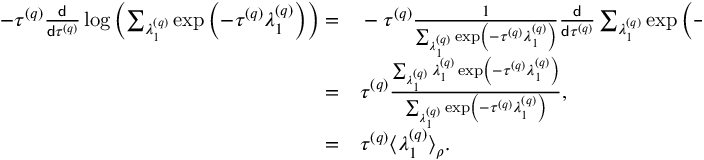<formula> <loc_0><loc_0><loc_500><loc_500>\begin{array} { r l } { - \tau ^ { \left ( q \right ) } \frac { d } { d \tau ^ { \left ( q \right ) } } \log \left ( \sum _ { \lambda _ { 1 } ^ { \left ( q \right ) } } \exp \left ( - \tau ^ { \left ( q \right ) } \lambda _ { 1 } ^ { \left ( q \right ) } \right ) \right ) = } & - \tau ^ { \left ( q \right ) } \frac { 1 } { \sum _ { \lambda _ { 1 } ^ { \left ( q \right ) } } \exp \left ( - \tau ^ { \left ( q \right ) } \lambda _ { 1 } ^ { \left ( q \right ) } \right ) } \frac { d } { d \tau ^ { \left ( q \right ) } } \sum _ { \lambda _ { 1 } ^ { \left ( q \right ) } } \exp \left ( - \tau ^ { \left ( q \right ) } \lambda _ { 1 } ^ { \left ( q \right ) } \right ) , } \\ { = } & \tau ^ { \left ( q \right ) } \frac { \sum _ { \lambda _ { 1 } ^ { \left ( q \right ) } } \lambda _ { 1 } ^ { \left ( q \right ) } \exp \left ( - \tau ^ { \left ( q \right ) } \lambda _ { 1 } ^ { \left ( q \right ) } \right ) } { \sum _ { \lambda _ { 1 } ^ { \left ( q \right ) } } \exp \left ( - \tau ^ { \left ( q \right ) } \lambda _ { 1 } ^ { \left ( q \right ) } \right ) } , } \\ { = } & \tau ^ { \left ( q \right ) } \left \langle \lambda _ { 1 } ^ { \left ( q \right ) } \right \rangle _ { \rho } . } \end{array}</formula> 